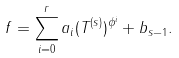Convert formula to latex. <formula><loc_0><loc_0><loc_500><loc_500>f = \sum _ { i = 0 } ^ { r } a _ { i } ( T ^ { ( s ) } ) ^ { \phi ^ { i } } + b _ { s - 1 } .</formula> 